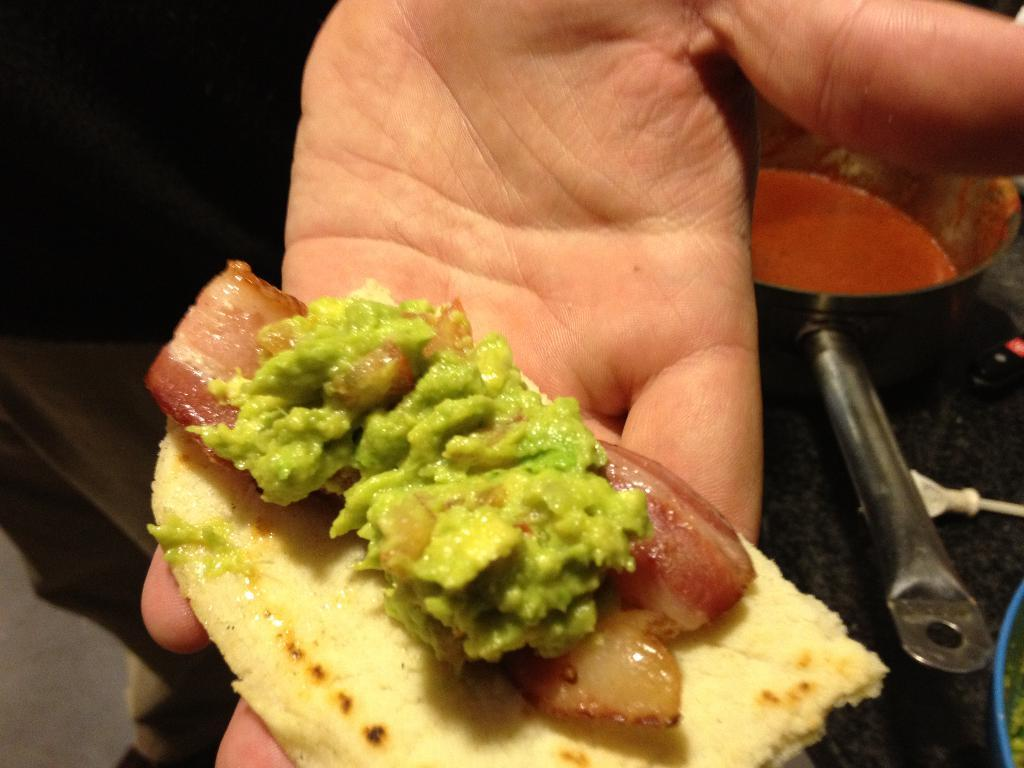Who is present in the image? There is a person in the image. What is the person holding in the image? The person is holding food in the image. What else can be seen in the image besides the person and food? There is a vessel containing liquid in the image. Can you describe the plate in the image? There is a plate on the right side of the image. How many beads are present on the person's grip in the image? There are no beads or grips mentioned in the image; it only features a person holding food, a vessel containing liquid, and a plate. 